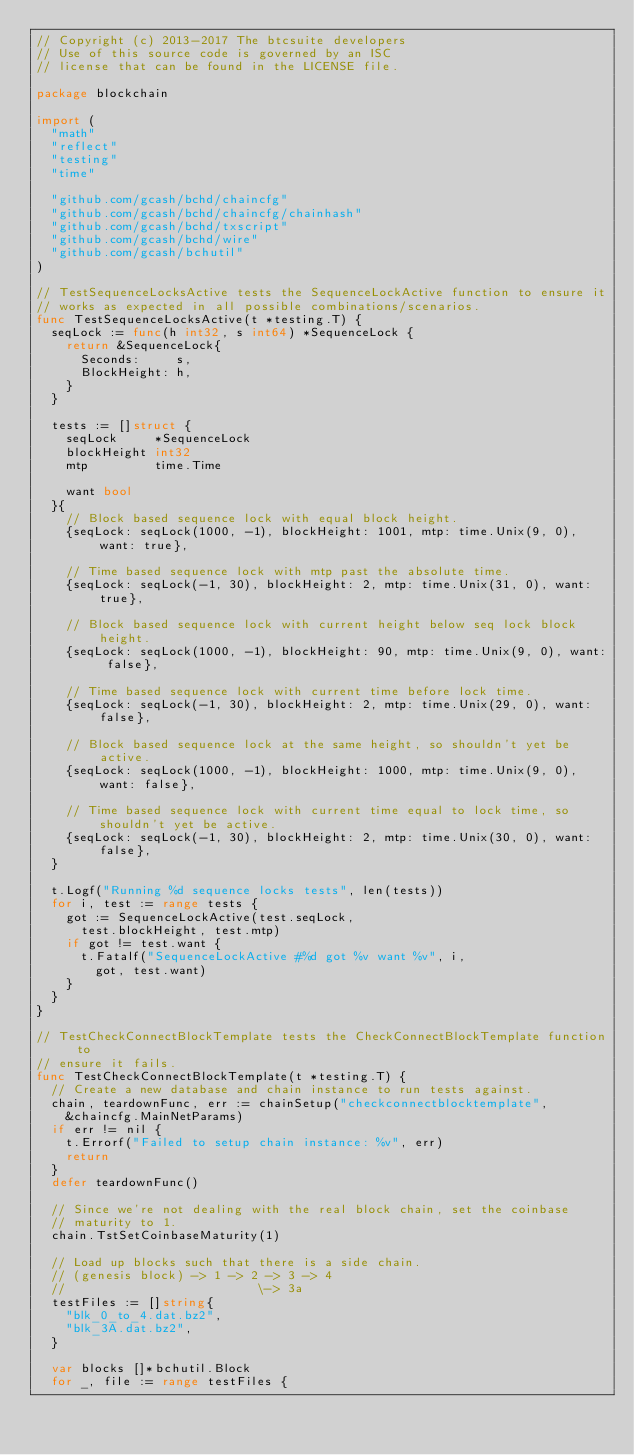<code> <loc_0><loc_0><loc_500><loc_500><_Go_>// Copyright (c) 2013-2017 The btcsuite developers
// Use of this source code is governed by an ISC
// license that can be found in the LICENSE file.

package blockchain

import (
	"math"
	"reflect"
	"testing"
	"time"

	"github.com/gcash/bchd/chaincfg"
	"github.com/gcash/bchd/chaincfg/chainhash"
	"github.com/gcash/bchd/txscript"
	"github.com/gcash/bchd/wire"
	"github.com/gcash/bchutil"
)

// TestSequenceLocksActive tests the SequenceLockActive function to ensure it
// works as expected in all possible combinations/scenarios.
func TestSequenceLocksActive(t *testing.T) {
	seqLock := func(h int32, s int64) *SequenceLock {
		return &SequenceLock{
			Seconds:     s,
			BlockHeight: h,
		}
	}

	tests := []struct {
		seqLock     *SequenceLock
		blockHeight int32
		mtp         time.Time

		want bool
	}{
		// Block based sequence lock with equal block height.
		{seqLock: seqLock(1000, -1), blockHeight: 1001, mtp: time.Unix(9, 0), want: true},

		// Time based sequence lock with mtp past the absolute time.
		{seqLock: seqLock(-1, 30), blockHeight: 2, mtp: time.Unix(31, 0), want: true},

		// Block based sequence lock with current height below seq lock block height.
		{seqLock: seqLock(1000, -1), blockHeight: 90, mtp: time.Unix(9, 0), want: false},

		// Time based sequence lock with current time before lock time.
		{seqLock: seqLock(-1, 30), blockHeight: 2, mtp: time.Unix(29, 0), want: false},

		// Block based sequence lock at the same height, so shouldn't yet be active.
		{seqLock: seqLock(1000, -1), blockHeight: 1000, mtp: time.Unix(9, 0), want: false},

		// Time based sequence lock with current time equal to lock time, so shouldn't yet be active.
		{seqLock: seqLock(-1, 30), blockHeight: 2, mtp: time.Unix(30, 0), want: false},
	}

	t.Logf("Running %d sequence locks tests", len(tests))
	for i, test := range tests {
		got := SequenceLockActive(test.seqLock,
			test.blockHeight, test.mtp)
		if got != test.want {
			t.Fatalf("SequenceLockActive #%d got %v want %v", i,
				got, test.want)
		}
	}
}

// TestCheckConnectBlockTemplate tests the CheckConnectBlockTemplate function to
// ensure it fails.
func TestCheckConnectBlockTemplate(t *testing.T) {
	// Create a new database and chain instance to run tests against.
	chain, teardownFunc, err := chainSetup("checkconnectblocktemplate",
		&chaincfg.MainNetParams)
	if err != nil {
		t.Errorf("Failed to setup chain instance: %v", err)
		return
	}
	defer teardownFunc()

	// Since we're not dealing with the real block chain, set the coinbase
	// maturity to 1.
	chain.TstSetCoinbaseMaturity(1)

	// Load up blocks such that there is a side chain.
	// (genesis block) -> 1 -> 2 -> 3 -> 4
	//                          \-> 3a
	testFiles := []string{
		"blk_0_to_4.dat.bz2",
		"blk_3A.dat.bz2",
	}

	var blocks []*bchutil.Block
	for _, file := range testFiles {</code> 